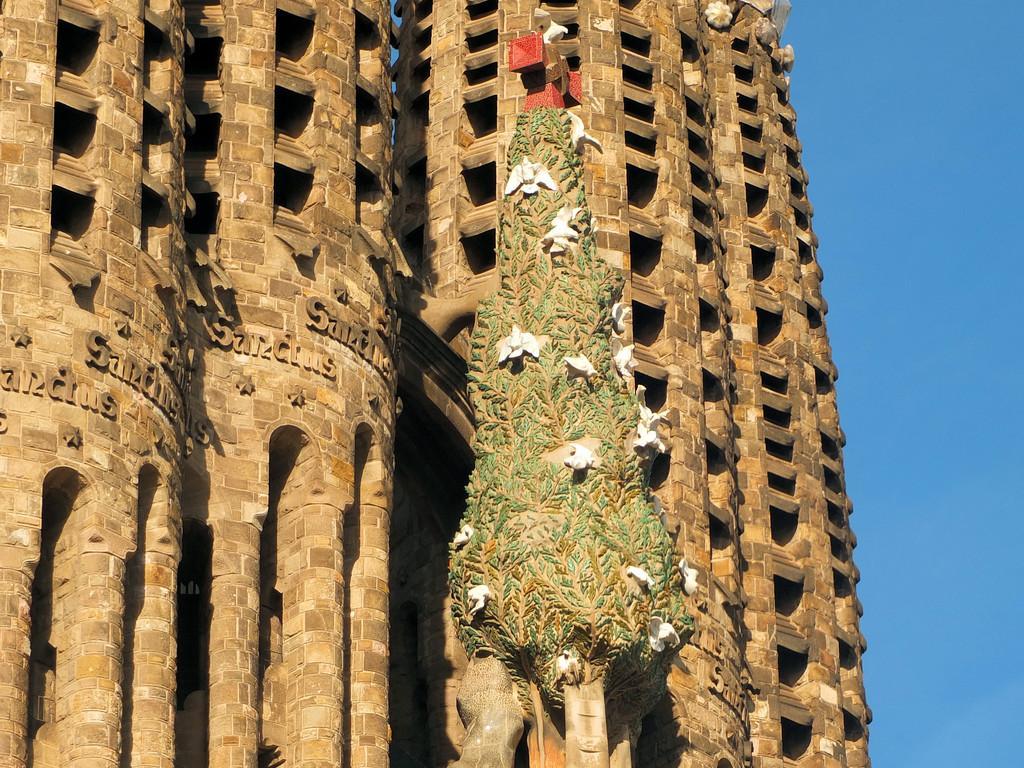Can you describe this image briefly? In this picture I can see a building, there is a tree structure with birds on it, and in the background there is the sky. 